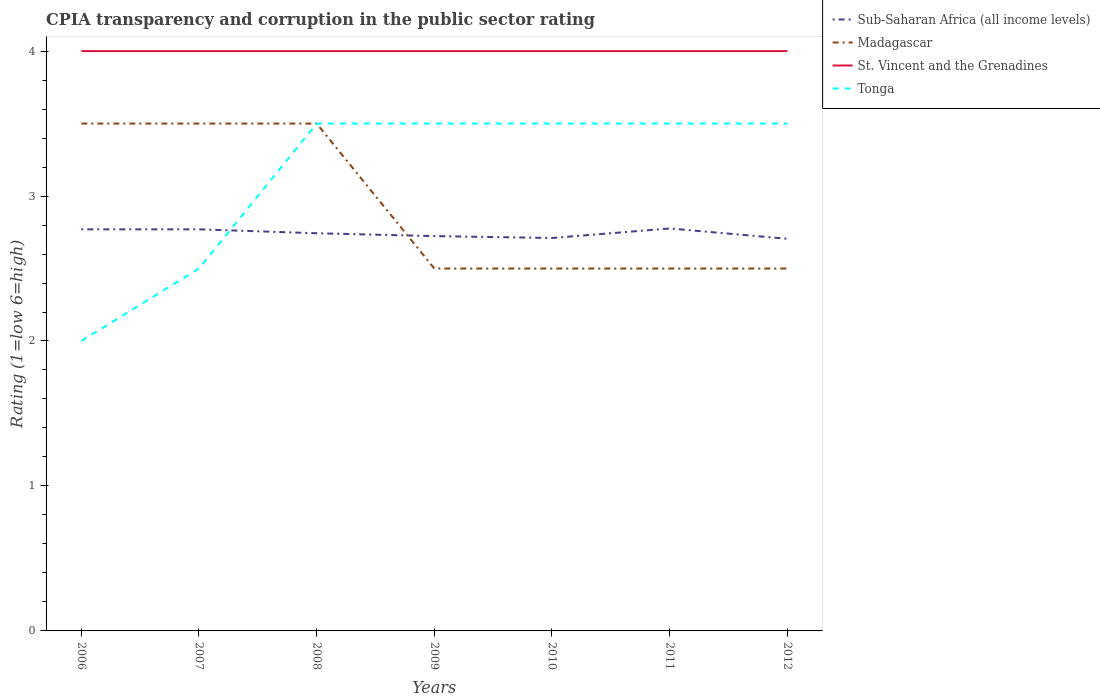Does the line corresponding to St. Vincent and the Grenadines intersect with the line corresponding to Sub-Saharan Africa (all income levels)?
Provide a short and direct response. No. What is the total CPIA rating in Sub-Saharan Africa (all income levels) in the graph?
Offer a very short reply. 0.03. What is the difference between the highest and the second highest CPIA rating in Sub-Saharan Africa (all income levels)?
Your answer should be compact. 0.07. What is the difference between the highest and the lowest CPIA rating in Tonga?
Your answer should be compact. 5. Is the CPIA rating in Sub-Saharan Africa (all income levels) strictly greater than the CPIA rating in St. Vincent and the Grenadines over the years?
Offer a terse response. Yes. How many lines are there?
Give a very brief answer. 4. How many years are there in the graph?
Make the answer very short. 7. What is the difference between two consecutive major ticks on the Y-axis?
Your answer should be compact. 1. Are the values on the major ticks of Y-axis written in scientific E-notation?
Provide a short and direct response. No. Where does the legend appear in the graph?
Provide a short and direct response. Top right. How many legend labels are there?
Keep it short and to the point. 4. How are the legend labels stacked?
Offer a very short reply. Vertical. What is the title of the graph?
Provide a succinct answer. CPIA transparency and corruption in the public sector rating. Does "Ghana" appear as one of the legend labels in the graph?
Provide a short and direct response. No. What is the label or title of the Y-axis?
Offer a very short reply. Rating (1=low 6=high). What is the Rating (1=low 6=high) in Sub-Saharan Africa (all income levels) in 2006?
Provide a short and direct response. 2.77. What is the Rating (1=low 6=high) of Madagascar in 2006?
Your response must be concise. 3.5. What is the Rating (1=low 6=high) in Sub-Saharan Africa (all income levels) in 2007?
Your answer should be compact. 2.77. What is the Rating (1=low 6=high) in St. Vincent and the Grenadines in 2007?
Your answer should be compact. 4. What is the Rating (1=low 6=high) of Tonga in 2007?
Make the answer very short. 2.5. What is the Rating (1=low 6=high) of Sub-Saharan Africa (all income levels) in 2008?
Ensure brevity in your answer.  2.74. What is the Rating (1=low 6=high) of Madagascar in 2008?
Provide a succinct answer. 3.5. What is the Rating (1=low 6=high) of St. Vincent and the Grenadines in 2008?
Ensure brevity in your answer.  4. What is the Rating (1=low 6=high) of Tonga in 2008?
Give a very brief answer. 3.5. What is the Rating (1=low 6=high) in Sub-Saharan Africa (all income levels) in 2009?
Your answer should be compact. 2.72. What is the Rating (1=low 6=high) in Madagascar in 2009?
Make the answer very short. 2.5. What is the Rating (1=low 6=high) in Tonga in 2009?
Your answer should be compact. 3.5. What is the Rating (1=low 6=high) of Sub-Saharan Africa (all income levels) in 2010?
Your response must be concise. 2.71. What is the Rating (1=low 6=high) of Sub-Saharan Africa (all income levels) in 2011?
Provide a succinct answer. 2.78. What is the Rating (1=low 6=high) in Madagascar in 2011?
Offer a very short reply. 2.5. What is the Rating (1=low 6=high) in Tonga in 2011?
Give a very brief answer. 3.5. What is the Rating (1=low 6=high) in Sub-Saharan Africa (all income levels) in 2012?
Keep it short and to the point. 2.71. What is the Rating (1=low 6=high) in Tonga in 2012?
Provide a succinct answer. 3.5. Across all years, what is the maximum Rating (1=low 6=high) of Sub-Saharan Africa (all income levels)?
Your response must be concise. 2.78. Across all years, what is the maximum Rating (1=low 6=high) in Madagascar?
Your response must be concise. 3.5. Across all years, what is the maximum Rating (1=low 6=high) in St. Vincent and the Grenadines?
Make the answer very short. 4. Across all years, what is the maximum Rating (1=low 6=high) of Tonga?
Make the answer very short. 3.5. Across all years, what is the minimum Rating (1=low 6=high) of Sub-Saharan Africa (all income levels)?
Give a very brief answer. 2.71. Across all years, what is the minimum Rating (1=low 6=high) of Madagascar?
Your response must be concise. 2.5. Across all years, what is the minimum Rating (1=low 6=high) in St. Vincent and the Grenadines?
Provide a succinct answer. 4. What is the total Rating (1=low 6=high) in Sub-Saharan Africa (all income levels) in the graph?
Give a very brief answer. 19.2. What is the total Rating (1=low 6=high) of Madagascar in the graph?
Offer a very short reply. 20.5. What is the total Rating (1=low 6=high) in St. Vincent and the Grenadines in the graph?
Ensure brevity in your answer.  28. What is the difference between the Rating (1=low 6=high) in Sub-Saharan Africa (all income levels) in 2006 and that in 2007?
Ensure brevity in your answer.  0. What is the difference between the Rating (1=low 6=high) of Madagascar in 2006 and that in 2007?
Make the answer very short. 0. What is the difference between the Rating (1=low 6=high) in Sub-Saharan Africa (all income levels) in 2006 and that in 2008?
Your answer should be compact. 0.03. What is the difference between the Rating (1=low 6=high) in Madagascar in 2006 and that in 2008?
Offer a very short reply. 0. What is the difference between the Rating (1=low 6=high) of Sub-Saharan Africa (all income levels) in 2006 and that in 2009?
Offer a very short reply. 0.05. What is the difference between the Rating (1=low 6=high) of Madagascar in 2006 and that in 2009?
Your answer should be very brief. 1. What is the difference between the Rating (1=low 6=high) of St. Vincent and the Grenadines in 2006 and that in 2009?
Provide a succinct answer. 0. What is the difference between the Rating (1=low 6=high) of Sub-Saharan Africa (all income levels) in 2006 and that in 2010?
Provide a short and direct response. 0.06. What is the difference between the Rating (1=low 6=high) in Madagascar in 2006 and that in 2010?
Make the answer very short. 1. What is the difference between the Rating (1=low 6=high) in Sub-Saharan Africa (all income levels) in 2006 and that in 2011?
Provide a short and direct response. -0.01. What is the difference between the Rating (1=low 6=high) in Sub-Saharan Africa (all income levels) in 2006 and that in 2012?
Provide a succinct answer. 0.07. What is the difference between the Rating (1=low 6=high) of St. Vincent and the Grenadines in 2006 and that in 2012?
Provide a succinct answer. 0. What is the difference between the Rating (1=low 6=high) in Sub-Saharan Africa (all income levels) in 2007 and that in 2008?
Your response must be concise. 0.03. What is the difference between the Rating (1=low 6=high) of St. Vincent and the Grenadines in 2007 and that in 2008?
Ensure brevity in your answer.  0. What is the difference between the Rating (1=low 6=high) of Sub-Saharan Africa (all income levels) in 2007 and that in 2009?
Your answer should be compact. 0.05. What is the difference between the Rating (1=low 6=high) of St. Vincent and the Grenadines in 2007 and that in 2009?
Keep it short and to the point. 0. What is the difference between the Rating (1=low 6=high) of Tonga in 2007 and that in 2009?
Your answer should be very brief. -1. What is the difference between the Rating (1=low 6=high) of Sub-Saharan Africa (all income levels) in 2007 and that in 2010?
Give a very brief answer. 0.06. What is the difference between the Rating (1=low 6=high) of Tonga in 2007 and that in 2010?
Make the answer very short. -1. What is the difference between the Rating (1=low 6=high) of Sub-Saharan Africa (all income levels) in 2007 and that in 2011?
Your answer should be very brief. -0.01. What is the difference between the Rating (1=low 6=high) of Madagascar in 2007 and that in 2011?
Your answer should be very brief. 1. What is the difference between the Rating (1=low 6=high) in St. Vincent and the Grenadines in 2007 and that in 2011?
Offer a very short reply. 0. What is the difference between the Rating (1=low 6=high) in Tonga in 2007 and that in 2011?
Offer a terse response. -1. What is the difference between the Rating (1=low 6=high) in Sub-Saharan Africa (all income levels) in 2007 and that in 2012?
Ensure brevity in your answer.  0.07. What is the difference between the Rating (1=low 6=high) in St. Vincent and the Grenadines in 2007 and that in 2012?
Offer a very short reply. 0. What is the difference between the Rating (1=low 6=high) in Sub-Saharan Africa (all income levels) in 2008 and that in 2009?
Keep it short and to the point. 0.02. What is the difference between the Rating (1=low 6=high) of Sub-Saharan Africa (all income levels) in 2008 and that in 2010?
Your response must be concise. 0.03. What is the difference between the Rating (1=low 6=high) in Sub-Saharan Africa (all income levels) in 2008 and that in 2011?
Make the answer very short. -0.03. What is the difference between the Rating (1=low 6=high) of Sub-Saharan Africa (all income levels) in 2008 and that in 2012?
Make the answer very short. 0.04. What is the difference between the Rating (1=low 6=high) of Madagascar in 2008 and that in 2012?
Offer a terse response. 1. What is the difference between the Rating (1=low 6=high) in St. Vincent and the Grenadines in 2008 and that in 2012?
Your answer should be compact. 0. What is the difference between the Rating (1=low 6=high) in Tonga in 2008 and that in 2012?
Keep it short and to the point. 0. What is the difference between the Rating (1=low 6=high) in Sub-Saharan Africa (all income levels) in 2009 and that in 2010?
Offer a terse response. 0.01. What is the difference between the Rating (1=low 6=high) in Tonga in 2009 and that in 2010?
Your answer should be compact. 0. What is the difference between the Rating (1=low 6=high) of Sub-Saharan Africa (all income levels) in 2009 and that in 2011?
Provide a succinct answer. -0.05. What is the difference between the Rating (1=low 6=high) of Madagascar in 2009 and that in 2011?
Provide a short and direct response. 0. What is the difference between the Rating (1=low 6=high) of Tonga in 2009 and that in 2011?
Provide a succinct answer. 0. What is the difference between the Rating (1=low 6=high) of Sub-Saharan Africa (all income levels) in 2009 and that in 2012?
Make the answer very short. 0.02. What is the difference between the Rating (1=low 6=high) in Madagascar in 2009 and that in 2012?
Offer a very short reply. 0. What is the difference between the Rating (1=low 6=high) of Tonga in 2009 and that in 2012?
Your answer should be compact. 0. What is the difference between the Rating (1=low 6=high) of Sub-Saharan Africa (all income levels) in 2010 and that in 2011?
Ensure brevity in your answer.  -0.07. What is the difference between the Rating (1=low 6=high) in Madagascar in 2010 and that in 2011?
Give a very brief answer. 0. What is the difference between the Rating (1=low 6=high) in St. Vincent and the Grenadines in 2010 and that in 2011?
Offer a terse response. 0. What is the difference between the Rating (1=low 6=high) of Tonga in 2010 and that in 2011?
Your answer should be compact. 0. What is the difference between the Rating (1=low 6=high) of Sub-Saharan Africa (all income levels) in 2010 and that in 2012?
Offer a very short reply. 0.01. What is the difference between the Rating (1=low 6=high) in Madagascar in 2010 and that in 2012?
Offer a terse response. 0. What is the difference between the Rating (1=low 6=high) of St. Vincent and the Grenadines in 2010 and that in 2012?
Provide a short and direct response. 0. What is the difference between the Rating (1=low 6=high) in Tonga in 2010 and that in 2012?
Give a very brief answer. 0. What is the difference between the Rating (1=low 6=high) in Sub-Saharan Africa (all income levels) in 2011 and that in 2012?
Provide a short and direct response. 0.07. What is the difference between the Rating (1=low 6=high) of Tonga in 2011 and that in 2012?
Offer a very short reply. 0. What is the difference between the Rating (1=low 6=high) in Sub-Saharan Africa (all income levels) in 2006 and the Rating (1=low 6=high) in Madagascar in 2007?
Your response must be concise. -0.73. What is the difference between the Rating (1=low 6=high) in Sub-Saharan Africa (all income levels) in 2006 and the Rating (1=low 6=high) in St. Vincent and the Grenadines in 2007?
Your answer should be compact. -1.23. What is the difference between the Rating (1=low 6=high) in Sub-Saharan Africa (all income levels) in 2006 and the Rating (1=low 6=high) in Tonga in 2007?
Provide a succinct answer. 0.27. What is the difference between the Rating (1=low 6=high) of Madagascar in 2006 and the Rating (1=low 6=high) of Tonga in 2007?
Ensure brevity in your answer.  1. What is the difference between the Rating (1=low 6=high) of Sub-Saharan Africa (all income levels) in 2006 and the Rating (1=low 6=high) of Madagascar in 2008?
Your response must be concise. -0.73. What is the difference between the Rating (1=low 6=high) in Sub-Saharan Africa (all income levels) in 2006 and the Rating (1=low 6=high) in St. Vincent and the Grenadines in 2008?
Your answer should be very brief. -1.23. What is the difference between the Rating (1=low 6=high) of Sub-Saharan Africa (all income levels) in 2006 and the Rating (1=low 6=high) of Tonga in 2008?
Provide a succinct answer. -0.73. What is the difference between the Rating (1=low 6=high) of Madagascar in 2006 and the Rating (1=low 6=high) of St. Vincent and the Grenadines in 2008?
Provide a succinct answer. -0.5. What is the difference between the Rating (1=low 6=high) of Madagascar in 2006 and the Rating (1=low 6=high) of Tonga in 2008?
Make the answer very short. 0. What is the difference between the Rating (1=low 6=high) of St. Vincent and the Grenadines in 2006 and the Rating (1=low 6=high) of Tonga in 2008?
Ensure brevity in your answer.  0.5. What is the difference between the Rating (1=low 6=high) in Sub-Saharan Africa (all income levels) in 2006 and the Rating (1=low 6=high) in Madagascar in 2009?
Your response must be concise. 0.27. What is the difference between the Rating (1=low 6=high) in Sub-Saharan Africa (all income levels) in 2006 and the Rating (1=low 6=high) in St. Vincent and the Grenadines in 2009?
Give a very brief answer. -1.23. What is the difference between the Rating (1=low 6=high) of Sub-Saharan Africa (all income levels) in 2006 and the Rating (1=low 6=high) of Tonga in 2009?
Provide a short and direct response. -0.73. What is the difference between the Rating (1=low 6=high) in Madagascar in 2006 and the Rating (1=low 6=high) in Tonga in 2009?
Your answer should be compact. 0. What is the difference between the Rating (1=low 6=high) of Sub-Saharan Africa (all income levels) in 2006 and the Rating (1=low 6=high) of Madagascar in 2010?
Your response must be concise. 0.27. What is the difference between the Rating (1=low 6=high) of Sub-Saharan Africa (all income levels) in 2006 and the Rating (1=low 6=high) of St. Vincent and the Grenadines in 2010?
Your answer should be very brief. -1.23. What is the difference between the Rating (1=low 6=high) in Sub-Saharan Africa (all income levels) in 2006 and the Rating (1=low 6=high) in Tonga in 2010?
Provide a short and direct response. -0.73. What is the difference between the Rating (1=low 6=high) in Madagascar in 2006 and the Rating (1=low 6=high) in St. Vincent and the Grenadines in 2010?
Your response must be concise. -0.5. What is the difference between the Rating (1=low 6=high) of Madagascar in 2006 and the Rating (1=low 6=high) of Tonga in 2010?
Offer a very short reply. 0. What is the difference between the Rating (1=low 6=high) in Sub-Saharan Africa (all income levels) in 2006 and the Rating (1=low 6=high) in Madagascar in 2011?
Offer a very short reply. 0.27. What is the difference between the Rating (1=low 6=high) in Sub-Saharan Africa (all income levels) in 2006 and the Rating (1=low 6=high) in St. Vincent and the Grenadines in 2011?
Offer a terse response. -1.23. What is the difference between the Rating (1=low 6=high) of Sub-Saharan Africa (all income levels) in 2006 and the Rating (1=low 6=high) of Tonga in 2011?
Give a very brief answer. -0.73. What is the difference between the Rating (1=low 6=high) in St. Vincent and the Grenadines in 2006 and the Rating (1=low 6=high) in Tonga in 2011?
Ensure brevity in your answer.  0.5. What is the difference between the Rating (1=low 6=high) of Sub-Saharan Africa (all income levels) in 2006 and the Rating (1=low 6=high) of Madagascar in 2012?
Make the answer very short. 0.27. What is the difference between the Rating (1=low 6=high) in Sub-Saharan Africa (all income levels) in 2006 and the Rating (1=low 6=high) in St. Vincent and the Grenadines in 2012?
Offer a terse response. -1.23. What is the difference between the Rating (1=low 6=high) of Sub-Saharan Africa (all income levels) in 2006 and the Rating (1=low 6=high) of Tonga in 2012?
Your answer should be compact. -0.73. What is the difference between the Rating (1=low 6=high) of Madagascar in 2006 and the Rating (1=low 6=high) of St. Vincent and the Grenadines in 2012?
Your answer should be compact. -0.5. What is the difference between the Rating (1=low 6=high) in Madagascar in 2006 and the Rating (1=low 6=high) in Tonga in 2012?
Provide a succinct answer. 0. What is the difference between the Rating (1=low 6=high) of St. Vincent and the Grenadines in 2006 and the Rating (1=low 6=high) of Tonga in 2012?
Make the answer very short. 0.5. What is the difference between the Rating (1=low 6=high) in Sub-Saharan Africa (all income levels) in 2007 and the Rating (1=low 6=high) in Madagascar in 2008?
Provide a short and direct response. -0.73. What is the difference between the Rating (1=low 6=high) in Sub-Saharan Africa (all income levels) in 2007 and the Rating (1=low 6=high) in St. Vincent and the Grenadines in 2008?
Your response must be concise. -1.23. What is the difference between the Rating (1=low 6=high) in Sub-Saharan Africa (all income levels) in 2007 and the Rating (1=low 6=high) in Tonga in 2008?
Your response must be concise. -0.73. What is the difference between the Rating (1=low 6=high) in Madagascar in 2007 and the Rating (1=low 6=high) in St. Vincent and the Grenadines in 2008?
Offer a very short reply. -0.5. What is the difference between the Rating (1=low 6=high) in Madagascar in 2007 and the Rating (1=low 6=high) in Tonga in 2008?
Make the answer very short. 0. What is the difference between the Rating (1=low 6=high) of St. Vincent and the Grenadines in 2007 and the Rating (1=low 6=high) of Tonga in 2008?
Offer a terse response. 0.5. What is the difference between the Rating (1=low 6=high) in Sub-Saharan Africa (all income levels) in 2007 and the Rating (1=low 6=high) in Madagascar in 2009?
Give a very brief answer. 0.27. What is the difference between the Rating (1=low 6=high) of Sub-Saharan Africa (all income levels) in 2007 and the Rating (1=low 6=high) of St. Vincent and the Grenadines in 2009?
Make the answer very short. -1.23. What is the difference between the Rating (1=low 6=high) of Sub-Saharan Africa (all income levels) in 2007 and the Rating (1=low 6=high) of Tonga in 2009?
Your response must be concise. -0.73. What is the difference between the Rating (1=low 6=high) of St. Vincent and the Grenadines in 2007 and the Rating (1=low 6=high) of Tonga in 2009?
Make the answer very short. 0.5. What is the difference between the Rating (1=low 6=high) of Sub-Saharan Africa (all income levels) in 2007 and the Rating (1=low 6=high) of Madagascar in 2010?
Your answer should be very brief. 0.27. What is the difference between the Rating (1=low 6=high) of Sub-Saharan Africa (all income levels) in 2007 and the Rating (1=low 6=high) of St. Vincent and the Grenadines in 2010?
Your response must be concise. -1.23. What is the difference between the Rating (1=low 6=high) of Sub-Saharan Africa (all income levels) in 2007 and the Rating (1=low 6=high) of Tonga in 2010?
Ensure brevity in your answer.  -0.73. What is the difference between the Rating (1=low 6=high) of Sub-Saharan Africa (all income levels) in 2007 and the Rating (1=low 6=high) of Madagascar in 2011?
Give a very brief answer. 0.27. What is the difference between the Rating (1=low 6=high) in Sub-Saharan Africa (all income levels) in 2007 and the Rating (1=low 6=high) in St. Vincent and the Grenadines in 2011?
Provide a succinct answer. -1.23. What is the difference between the Rating (1=low 6=high) in Sub-Saharan Africa (all income levels) in 2007 and the Rating (1=low 6=high) in Tonga in 2011?
Your response must be concise. -0.73. What is the difference between the Rating (1=low 6=high) of Madagascar in 2007 and the Rating (1=low 6=high) of Tonga in 2011?
Provide a succinct answer. 0. What is the difference between the Rating (1=low 6=high) in St. Vincent and the Grenadines in 2007 and the Rating (1=low 6=high) in Tonga in 2011?
Your response must be concise. 0.5. What is the difference between the Rating (1=low 6=high) of Sub-Saharan Africa (all income levels) in 2007 and the Rating (1=low 6=high) of Madagascar in 2012?
Your answer should be very brief. 0.27. What is the difference between the Rating (1=low 6=high) in Sub-Saharan Africa (all income levels) in 2007 and the Rating (1=low 6=high) in St. Vincent and the Grenadines in 2012?
Your response must be concise. -1.23. What is the difference between the Rating (1=low 6=high) of Sub-Saharan Africa (all income levels) in 2007 and the Rating (1=low 6=high) of Tonga in 2012?
Give a very brief answer. -0.73. What is the difference between the Rating (1=low 6=high) of St. Vincent and the Grenadines in 2007 and the Rating (1=low 6=high) of Tonga in 2012?
Ensure brevity in your answer.  0.5. What is the difference between the Rating (1=low 6=high) of Sub-Saharan Africa (all income levels) in 2008 and the Rating (1=low 6=high) of Madagascar in 2009?
Your answer should be very brief. 0.24. What is the difference between the Rating (1=low 6=high) in Sub-Saharan Africa (all income levels) in 2008 and the Rating (1=low 6=high) in St. Vincent and the Grenadines in 2009?
Ensure brevity in your answer.  -1.26. What is the difference between the Rating (1=low 6=high) in Sub-Saharan Africa (all income levels) in 2008 and the Rating (1=low 6=high) in Tonga in 2009?
Your response must be concise. -0.76. What is the difference between the Rating (1=low 6=high) of Madagascar in 2008 and the Rating (1=low 6=high) of St. Vincent and the Grenadines in 2009?
Your answer should be very brief. -0.5. What is the difference between the Rating (1=low 6=high) in Sub-Saharan Africa (all income levels) in 2008 and the Rating (1=low 6=high) in Madagascar in 2010?
Offer a terse response. 0.24. What is the difference between the Rating (1=low 6=high) in Sub-Saharan Africa (all income levels) in 2008 and the Rating (1=low 6=high) in St. Vincent and the Grenadines in 2010?
Offer a terse response. -1.26. What is the difference between the Rating (1=low 6=high) in Sub-Saharan Africa (all income levels) in 2008 and the Rating (1=low 6=high) in Tonga in 2010?
Ensure brevity in your answer.  -0.76. What is the difference between the Rating (1=low 6=high) of Madagascar in 2008 and the Rating (1=low 6=high) of Tonga in 2010?
Offer a terse response. 0. What is the difference between the Rating (1=low 6=high) in Sub-Saharan Africa (all income levels) in 2008 and the Rating (1=low 6=high) in Madagascar in 2011?
Your answer should be very brief. 0.24. What is the difference between the Rating (1=low 6=high) in Sub-Saharan Africa (all income levels) in 2008 and the Rating (1=low 6=high) in St. Vincent and the Grenadines in 2011?
Provide a short and direct response. -1.26. What is the difference between the Rating (1=low 6=high) in Sub-Saharan Africa (all income levels) in 2008 and the Rating (1=low 6=high) in Tonga in 2011?
Give a very brief answer. -0.76. What is the difference between the Rating (1=low 6=high) of St. Vincent and the Grenadines in 2008 and the Rating (1=low 6=high) of Tonga in 2011?
Offer a terse response. 0.5. What is the difference between the Rating (1=low 6=high) of Sub-Saharan Africa (all income levels) in 2008 and the Rating (1=low 6=high) of Madagascar in 2012?
Your answer should be very brief. 0.24. What is the difference between the Rating (1=low 6=high) of Sub-Saharan Africa (all income levels) in 2008 and the Rating (1=low 6=high) of St. Vincent and the Grenadines in 2012?
Your response must be concise. -1.26. What is the difference between the Rating (1=low 6=high) of Sub-Saharan Africa (all income levels) in 2008 and the Rating (1=low 6=high) of Tonga in 2012?
Offer a terse response. -0.76. What is the difference between the Rating (1=low 6=high) of Madagascar in 2008 and the Rating (1=low 6=high) of St. Vincent and the Grenadines in 2012?
Your answer should be very brief. -0.5. What is the difference between the Rating (1=low 6=high) in Sub-Saharan Africa (all income levels) in 2009 and the Rating (1=low 6=high) in Madagascar in 2010?
Make the answer very short. 0.22. What is the difference between the Rating (1=low 6=high) of Sub-Saharan Africa (all income levels) in 2009 and the Rating (1=low 6=high) of St. Vincent and the Grenadines in 2010?
Your answer should be compact. -1.28. What is the difference between the Rating (1=low 6=high) of Sub-Saharan Africa (all income levels) in 2009 and the Rating (1=low 6=high) of Tonga in 2010?
Offer a terse response. -0.78. What is the difference between the Rating (1=low 6=high) of Madagascar in 2009 and the Rating (1=low 6=high) of Tonga in 2010?
Offer a very short reply. -1. What is the difference between the Rating (1=low 6=high) in Sub-Saharan Africa (all income levels) in 2009 and the Rating (1=low 6=high) in Madagascar in 2011?
Offer a very short reply. 0.22. What is the difference between the Rating (1=low 6=high) in Sub-Saharan Africa (all income levels) in 2009 and the Rating (1=low 6=high) in St. Vincent and the Grenadines in 2011?
Your response must be concise. -1.28. What is the difference between the Rating (1=low 6=high) of Sub-Saharan Africa (all income levels) in 2009 and the Rating (1=low 6=high) of Tonga in 2011?
Provide a short and direct response. -0.78. What is the difference between the Rating (1=low 6=high) of Madagascar in 2009 and the Rating (1=low 6=high) of Tonga in 2011?
Provide a succinct answer. -1. What is the difference between the Rating (1=low 6=high) in St. Vincent and the Grenadines in 2009 and the Rating (1=low 6=high) in Tonga in 2011?
Your response must be concise. 0.5. What is the difference between the Rating (1=low 6=high) in Sub-Saharan Africa (all income levels) in 2009 and the Rating (1=low 6=high) in Madagascar in 2012?
Your answer should be very brief. 0.22. What is the difference between the Rating (1=low 6=high) in Sub-Saharan Africa (all income levels) in 2009 and the Rating (1=low 6=high) in St. Vincent and the Grenadines in 2012?
Offer a very short reply. -1.28. What is the difference between the Rating (1=low 6=high) of Sub-Saharan Africa (all income levels) in 2009 and the Rating (1=low 6=high) of Tonga in 2012?
Offer a very short reply. -0.78. What is the difference between the Rating (1=low 6=high) in Madagascar in 2009 and the Rating (1=low 6=high) in St. Vincent and the Grenadines in 2012?
Ensure brevity in your answer.  -1.5. What is the difference between the Rating (1=low 6=high) of St. Vincent and the Grenadines in 2009 and the Rating (1=low 6=high) of Tonga in 2012?
Make the answer very short. 0.5. What is the difference between the Rating (1=low 6=high) in Sub-Saharan Africa (all income levels) in 2010 and the Rating (1=low 6=high) in Madagascar in 2011?
Provide a succinct answer. 0.21. What is the difference between the Rating (1=low 6=high) of Sub-Saharan Africa (all income levels) in 2010 and the Rating (1=low 6=high) of St. Vincent and the Grenadines in 2011?
Offer a terse response. -1.29. What is the difference between the Rating (1=low 6=high) of Sub-Saharan Africa (all income levels) in 2010 and the Rating (1=low 6=high) of Tonga in 2011?
Offer a terse response. -0.79. What is the difference between the Rating (1=low 6=high) in Madagascar in 2010 and the Rating (1=low 6=high) in Tonga in 2011?
Offer a very short reply. -1. What is the difference between the Rating (1=low 6=high) in St. Vincent and the Grenadines in 2010 and the Rating (1=low 6=high) in Tonga in 2011?
Your response must be concise. 0.5. What is the difference between the Rating (1=low 6=high) in Sub-Saharan Africa (all income levels) in 2010 and the Rating (1=low 6=high) in Madagascar in 2012?
Ensure brevity in your answer.  0.21. What is the difference between the Rating (1=low 6=high) in Sub-Saharan Africa (all income levels) in 2010 and the Rating (1=low 6=high) in St. Vincent and the Grenadines in 2012?
Provide a short and direct response. -1.29. What is the difference between the Rating (1=low 6=high) of Sub-Saharan Africa (all income levels) in 2010 and the Rating (1=low 6=high) of Tonga in 2012?
Your response must be concise. -0.79. What is the difference between the Rating (1=low 6=high) of St. Vincent and the Grenadines in 2010 and the Rating (1=low 6=high) of Tonga in 2012?
Give a very brief answer. 0.5. What is the difference between the Rating (1=low 6=high) in Sub-Saharan Africa (all income levels) in 2011 and the Rating (1=low 6=high) in Madagascar in 2012?
Provide a short and direct response. 0.28. What is the difference between the Rating (1=low 6=high) in Sub-Saharan Africa (all income levels) in 2011 and the Rating (1=low 6=high) in St. Vincent and the Grenadines in 2012?
Provide a succinct answer. -1.22. What is the difference between the Rating (1=low 6=high) of Sub-Saharan Africa (all income levels) in 2011 and the Rating (1=low 6=high) of Tonga in 2012?
Keep it short and to the point. -0.72. What is the difference between the Rating (1=low 6=high) in Madagascar in 2011 and the Rating (1=low 6=high) in St. Vincent and the Grenadines in 2012?
Offer a very short reply. -1.5. What is the difference between the Rating (1=low 6=high) in Madagascar in 2011 and the Rating (1=low 6=high) in Tonga in 2012?
Provide a short and direct response. -1. What is the difference between the Rating (1=low 6=high) in St. Vincent and the Grenadines in 2011 and the Rating (1=low 6=high) in Tonga in 2012?
Keep it short and to the point. 0.5. What is the average Rating (1=low 6=high) of Sub-Saharan Africa (all income levels) per year?
Your answer should be compact. 2.74. What is the average Rating (1=low 6=high) in Madagascar per year?
Make the answer very short. 2.93. What is the average Rating (1=low 6=high) of Tonga per year?
Provide a short and direct response. 3.14. In the year 2006, what is the difference between the Rating (1=low 6=high) of Sub-Saharan Africa (all income levels) and Rating (1=low 6=high) of Madagascar?
Give a very brief answer. -0.73. In the year 2006, what is the difference between the Rating (1=low 6=high) of Sub-Saharan Africa (all income levels) and Rating (1=low 6=high) of St. Vincent and the Grenadines?
Ensure brevity in your answer.  -1.23. In the year 2006, what is the difference between the Rating (1=low 6=high) of Sub-Saharan Africa (all income levels) and Rating (1=low 6=high) of Tonga?
Your response must be concise. 0.77. In the year 2006, what is the difference between the Rating (1=low 6=high) in Madagascar and Rating (1=low 6=high) in St. Vincent and the Grenadines?
Provide a short and direct response. -0.5. In the year 2006, what is the difference between the Rating (1=low 6=high) of Madagascar and Rating (1=low 6=high) of Tonga?
Offer a very short reply. 1.5. In the year 2006, what is the difference between the Rating (1=low 6=high) in St. Vincent and the Grenadines and Rating (1=low 6=high) in Tonga?
Give a very brief answer. 2. In the year 2007, what is the difference between the Rating (1=low 6=high) in Sub-Saharan Africa (all income levels) and Rating (1=low 6=high) in Madagascar?
Give a very brief answer. -0.73. In the year 2007, what is the difference between the Rating (1=low 6=high) of Sub-Saharan Africa (all income levels) and Rating (1=low 6=high) of St. Vincent and the Grenadines?
Give a very brief answer. -1.23. In the year 2007, what is the difference between the Rating (1=low 6=high) in Sub-Saharan Africa (all income levels) and Rating (1=low 6=high) in Tonga?
Your answer should be very brief. 0.27. In the year 2007, what is the difference between the Rating (1=low 6=high) in Madagascar and Rating (1=low 6=high) in Tonga?
Keep it short and to the point. 1. In the year 2007, what is the difference between the Rating (1=low 6=high) in St. Vincent and the Grenadines and Rating (1=low 6=high) in Tonga?
Offer a terse response. 1.5. In the year 2008, what is the difference between the Rating (1=low 6=high) of Sub-Saharan Africa (all income levels) and Rating (1=low 6=high) of Madagascar?
Ensure brevity in your answer.  -0.76. In the year 2008, what is the difference between the Rating (1=low 6=high) of Sub-Saharan Africa (all income levels) and Rating (1=low 6=high) of St. Vincent and the Grenadines?
Provide a short and direct response. -1.26. In the year 2008, what is the difference between the Rating (1=low 6=high) in Sub-Saharan Africa (all income levels) and Rating (1=low 6=high) in Tonga?
Give a very brief answer. -0.76. In the year 2008, what is the difference between the Rating (1=low 6=high) of Madagascar and Rating (1=low 6=high) of Tonga?
Keep it short and to the point. 0. In the year 2009, what is the difference between the Rating (1=low 6=high) in Sub-Saharan Africa (all income levels) and Rating (1=low 6=high) in Madagascar?
Offer a terse response. 0.22. In the year 2009, what is the difference between the Rating (1=low 6=high) of Sub-Saharan Africa (all income levels) and Rating (1=low 6=high) of St. Vincent and the Grenadines?
Ensure brevity in your answer.  -1.28. In the year 2009, what is the difference between the Rating (1=low 6=high) of Sub-Saharan Africa (all income levels) and Rating (1=low 6=high) of Tonga?
Provide a succinct answer. -0.78. In the year 2010, what is the difference between the Rating (1=low 6=high) in Sub-Saharan Africa (all income levels) and Rating (1=low 6=high) in Madagascar?
Your answer should be compact. 0.21. In the year 2010, what is the difference between the Rating (1=low 6=high) of Sub-Saharan Africa (all income levels) and Rating (1=low 6=high) of St. Vincent and the Grenadines?
Your answer should be very brief. -1.29. In the year 2010, what is the difference between the Rating (1=low 6=high) of Sub-Saharan Africa (all income levels) and Rating (1=low 6=high) of Tonga?
Your answer should be very brief. -0.79. In the year 2010, what is the difference between the Rating (1=low 6=high) in St. Vincent and the Grenadines and Rating (1=low 6=high) in Tonga?
Give a very brief answer. 0.5. In the year 2011, what is the difference between the Rating (1=low 6=high) of Sub-Saharan Africa (all income levels) and Rating (1=low 6=high) of Madagascar?
Keep it short and to the point. 0.28. In the year 2011, what is the difference between the Rating (1=low 6=high) of Sub-Saharan Africa (all income levels) and Rating (1=low 6=high) of St. Vincent and the Grenadines?
Your response must be concise. -1.22. In the year 2011, what is the difference between the Rating (1=low 6=high) in Sub-Saharan Africa (all income levels) and Rating (1=low 6=high) in Tonga?
Give a very brief answer. -0.72. In the year 2011, what is the difference between the Rating (1=low 6=high) in Madagascar and Rating (1=low 6=high) in Tonga?
Your response must be concise. -1. In the year 2011, what is the difference between the Rating (1=low 6=high) of St. Vincent and the Grenadines and Rating (1=low 6=high) of Tonga?
Offer a very short reply. 0.5. In the year 2012, what is the difference between the Rating (1=low 6=high) in Sub-Saharan Africa (all income levels) and Rating (1=low 6=high) in Madagascar?
Keep it short and to the point. 0.21. In the year 2012, what is the difference between the Rating (1=low 6=high) of Sub-Saharan Africa (all income levels) and Rating (1=low 6=high) of St. Vincent and the Grenadines?
Provide a short and direct response. -1.29. In the year 2012, what is the difference between the Rating (1=low 6=high) in Sub-Saharan Africa (all income levels) and Rating (1=low 6=high) in Tonga?
Ensure brevity in your answer.  -0.79. In the year 2012, what is the difference between the Rating (1=low 6=high) in Madagascar and Rating (1=low 6=high) in St. Vincent and the Grenadines?
Make the answer very short. -1.5. In the year 2012, what is the difference between the Rating (1=low 6=high) in Madagascar and Rating (1=low 6=high) in Tonga?
Ensure brevity in your answer.  -1. What is the ratio of the Rating (1=low 6=high) of Madagascar in 2006 to that in 2007?
Provide a succinct answer. 1. What is the ratio of the Rating (1=low 6=high) in St. Vincent and the Grenadines in 2006 to that in 2007?
Give a very brief answer. 1. What is the ratio of the Rating (1=low 6=high) of Sub-Saharan Africa (all income levels) in 2006 to that in 2008?
Provide a short and direct response. 1.01. What is the ratio of the Rating (1=low 6=high) of St. Vincent and the Grenadines in 2006 to that in 2008?
Provide a short and direct response. 1. What is the ratio of the Rating (1=low 6=high) in Tonga in 2006 to that in 2008?
Your answer should be very brief. 0.57. What is the ratio of the Rating (1=low 6=high) of Sub-Saharan Africa (all income levels) in 2006 to that in 2009?
Provide a succinct answer. 1.02. What is the ratio of the Rating (1=low 6=high) of St. Vincent and the Grenadines in 2006 to that in 2009?
Make the answer very short. 1. What is the ratio of the Rating (1=low 6=high) of Tonga in 2006 to that in 2009?
Your answer should be compact. 0.57. What is the ratio of the Rating (1=low 6=high) of Madagascar in 2006 to that in 2010?
Offer a very short reply. 1.4. What is the ratio of the Rating (1=low 6=high) in Tonga in 2006 to that in 2011?
Make the answer very short. 0.57. What is the ratio of the Rating (1=low 6=high) of Sub-Saharan Africa (all income levels) in 2006 to that in 2012?
Provide a short and direct response. 1.02. What is the ratio of the Rating (1=low 6=high) of Madagascar in 2006 to that in 2012?
Your answer should be very brief. 1.4. What is the ratio of the Rating (1=low 6=high) of St. Vincent and the Grenadines in 2006 to that in 2012?
Your answer should be very brief. 1. What is the ratio of the Rating (1=low 6=high) in Sub-Saharan Africa (all income levels) in 2007 to that in 2008?
Your answer should be very brief. 1.01. What is the ratio of the Rating (1=low 6=high) in Tonga in 2007 to that in 2008?
Give a very brief answer. 0.71. What is the ratio of the Rating (1=low 6=high) in Sub-Saharan Africa (all income levels) in 2007 to that in 2009?
Make the answer very short. 1.02. What is the ratio of the Rating (1=low 6=high) of St. Vincent and the Grenadines in 2007 to that in 2009?
Your response must be concise. 1. What is the ratio of the Rating (1=low 6=high) of Sub-Saharan Africa (all income levels) in 2007 to that in 2010?
Provide a succinct answer. 1.02. What is the ratio of the Rating (1=low 6=high) in Sub-Saharan Africa (all income levels) in 2007 to that in 2011?
Ensure brevity in your answer.  1. What is the ratio of the Rating (1=low 6=high) of Tonga in 2007 to that in 2011?
Give a very brief answer. 0.71. What is the ratio of the Rating (1=low 6=high) in Sub-Saharan Africa (all income levels) in 2007 to that in 2012?
Your answer should be compact. 1.02. What is the ratio of the Rating (1=low 6=high) in Madagascar in 2007 to that in 2012?
Your response must be concise. 1.4. What is the ratio of the Rating (1=low 6=high) in St. Vincent and the Grenadines in 2007 to that in 2012?
Provide a succinct answer. 1. What is the ratio of the Rating (1=low 6=high) of Madagascar in 2008 to that in 2009?
Your response must be concise. 1.4. What is the ratio of the Rating (1=low 6=high) in Sub-Saharan Africa (all income levels) in 2008 to that in 2010?
Your answer should be compact. 1.01. What is the ratio of the Rating (1=low 6=high) of Madagascar in 2008 to that in 2010?
Ensure brevity in your answer.  1.4. What is the ratio of the Rating (1=low 6=high) of St. Vincent and the Grenadines in 2008 to that in 2010?
Make the answer very short. 1. What is the ratio of the Rating (1=low 6=high) in Tonga in 2008 to that in 2010?
Ensure brevity in your answer.  1. What is the ratio of the Rating (1=low 6=high) of St. Vincent and the Grenadines in 2008 to that in 2011?
Your answer should be compact. 1. What is the ratio of the Rating (1=low 6=high) of Sub-Saharan Africa (all income levels) in 2008 to that in 2012?
Offer a very short reply. 1.01. What is the ratio of the Rating (1=low 6=high) of Madagascar in 2008 to that in 2012?
Keep it short and to the point. 1.4. What is the ratio of the Rating (1=low 6=high) of Tonga in 2008 to that in 2012?
Provide a short and direct response. 1. What is the ratio of the Rating (1=low 6=high) of Sub-Saharan Africa (all income levels) in 2009 to that in 2010?
Provide a succinct answer. 1. What is the ratio of the Rating (1=low 6=high) in Madagascar in 2009 to that in 2010?
Provide a short and direct response. 1. What is the ratio of the Rating (1=low 6=high) in St. Vincent and the Grenadines in 2009 to that in 2010?
Your answer should be compact. 1. What is the ratio of the Rating (1=low 6=high) of Tonga in 2009 to that in 2010?
Provide a short and direct response. 1. What is the ratio of the Rating (1=low 6=high) of Sub-Saharan Africa (all income levels) in 2009 to that in 2011?
Make the answer very short. 0.98. What is the ratio of the Rating (1=low 6=high) of Madagascar in 2009 to that in 2011?
Keep it short and to the point. 1. What is the ratio of the Rating (1=low 6=high) in St. Vincent and the Grenadines in 2009 to that in 2011?
Give a very brief answer. 1. What is the ratio of the Rating (1=low 6=high) of Sub-Saharan Africa (all income levels) in 2009 to that in 2012?
Your answer should be very brief. 1.01. What is the ratio of the Rating (1=low 6=high) of St. Vincent and the Grenadines in 2009 to that in 2012?
Offer a terse response. 1. What is the ratio of the Rating (1=low 6=high) in Sub-Saharan Africa (all income levels) in 2010 to that in 2011?
Your answer should be compact. 0.98. What is the ratio of the Rating (1=low 6=high) in Tonga in 2010 to that in 2011?
Keep it short and to the point. 1. What is the ratio of the Rating (1=low 6=high) in Sub-Saharan Africa (all income levels) in 2010 to that in 2012?
Ensure brevity in your answer.  1. What is the ratio of the Rating (1=low 6=high) of Madagascar in 2010 to that in 2012?
Your response must be concise. 1. What is the ratio of the Rating (1=low 6=high) in St. Vincent and the Grenadines in 2010 to that in 2012?
Your answer should be compact. 1. What is the ratio of the Rating (1=low 6=high) in Tonga in 2010 to that in 2012?
Provide a short and direct response. 1. What is the ratio of the Rating (1=low 6=high) of Sub-Saharan Africa (all income levels) in 2011 to that in 2012?
Your response must be concise. 1.03. What is the difference between the highest and the second highest Rating (1=low 6=high) of Sub-Saharan Africa (all income levels)?
Ensure brevity in your answer.  0.01. What is the difference between the highest and the second highest Rating (1=low 6=high) of Madagascar?
Provide a succinct answer. 0. What is the difference between the highest and the second highest Rating (1=low 6=high) of St. Vincent and the Grenadines?
Provide a succinct answer. 0. What is the difference between the highest and the second highest Rating (1=low 6=high) of Tonga?
Give a very brief answer. 0. What is the difference between the highest and the lowest Rating (1=low 6=high) in Sub-Saharan Africa (all income levels)?
Keep it short and to the point. 0.07. What is the difference between the highest and the lowest Rating (1=low 6=high) in Madagascar?
Ensure brevity in your answer.  1. What is the difference between the highest and the lowest Rating (1=low 6=high) in Tonga?
Keep it short and to the point. 1.5. 